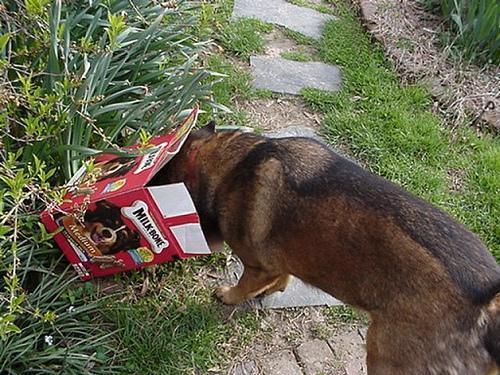How many pets in the photo?
Give a very brief answer. 1. 